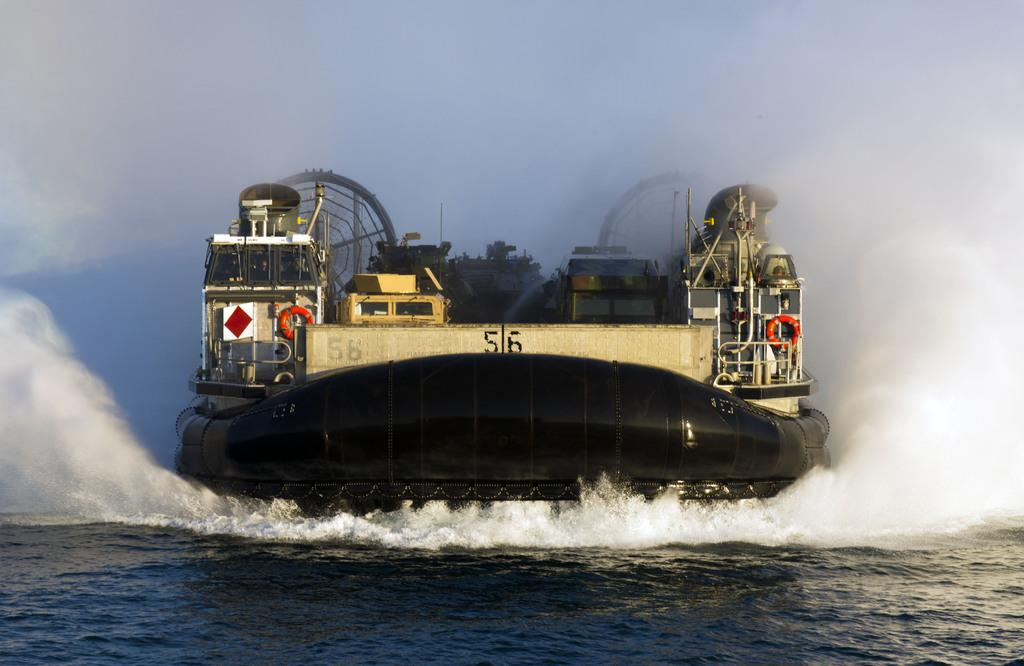What is the main subject of the image? The main subject of the image is a big ship. What is the color of the ship? The ship is black in color. What is present at the bottom of the image? There is water at the bottom of the image. What is visible at the top of the image? The sky is visible at the top of the image. How many bulbs are illuminated on the ship in the image? There are no bulbs visible on the ship in the image. What type of experience can be gained from the ship in the image? The image does not provide information about the experience one might have from the ship. 